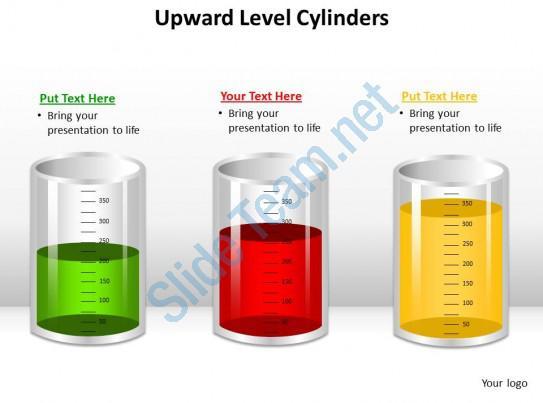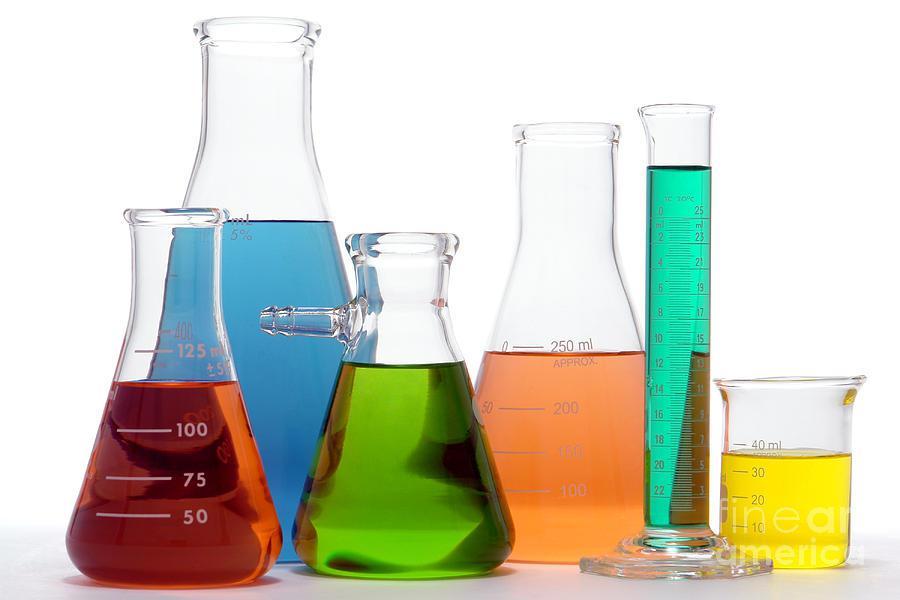The first image is the image on the left, the second image is the image on the right. For the images shown, is this caption "Three containers with brightly colored liquid sit together in the image on the left." true? Answer yes or no. Yes. The first image is the image on the left, the second image is the image on the right. Examine the images to the left and right. Is the description "In at least one image there are three cylinders filled with different colors of water." accurate? Answer yes or no. Yes. 